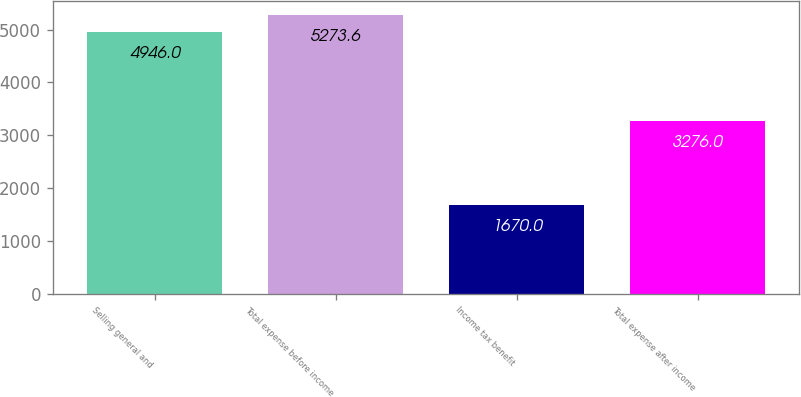Convert chart to OTSL. <chart><loc_0><loc_0><loc_500><loc_500><bar_chart><fcel>Selling general and<fcel>Total expense before income<fcel>Income tax benefit<fcel>Total expense after income<nl><fcel>4946<fcel>5273.6<fcel>1670<fcel>3276<nl></chart> 